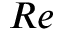<formula> <loc_0><loc_0><loc_500><loc_500>R e</formula> 